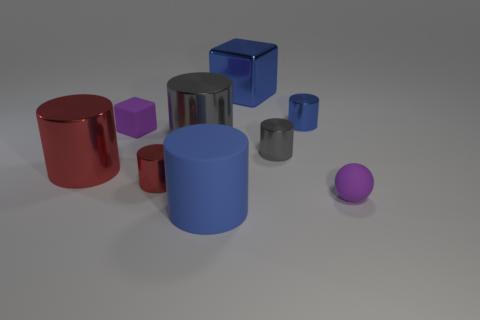Subtract all large red shiny cylinders. How many cylinders are left? 5 Subtract all gray cylinders. How many cylinders are left? 4 Subtract 2 cylinders. How many cylinders are left? 4 Subtract all green cylinders. Subtract all brown cubes. How many cylinders are left? 6 Add 1 red metallic objects. How many objects exist? 10 Subtract all cylinders. How many objects are left? 3 Add 6 tiny red cylinders. How many tiny red cylinders are left? 7 Add 4 metal cylinders. How many metal cylinders exist? 9 Subtract 0 brown balls. How many objects are left? 9 Subtract all big brown cylinders. Subtract all small purple objects. How many objects are left? 7 